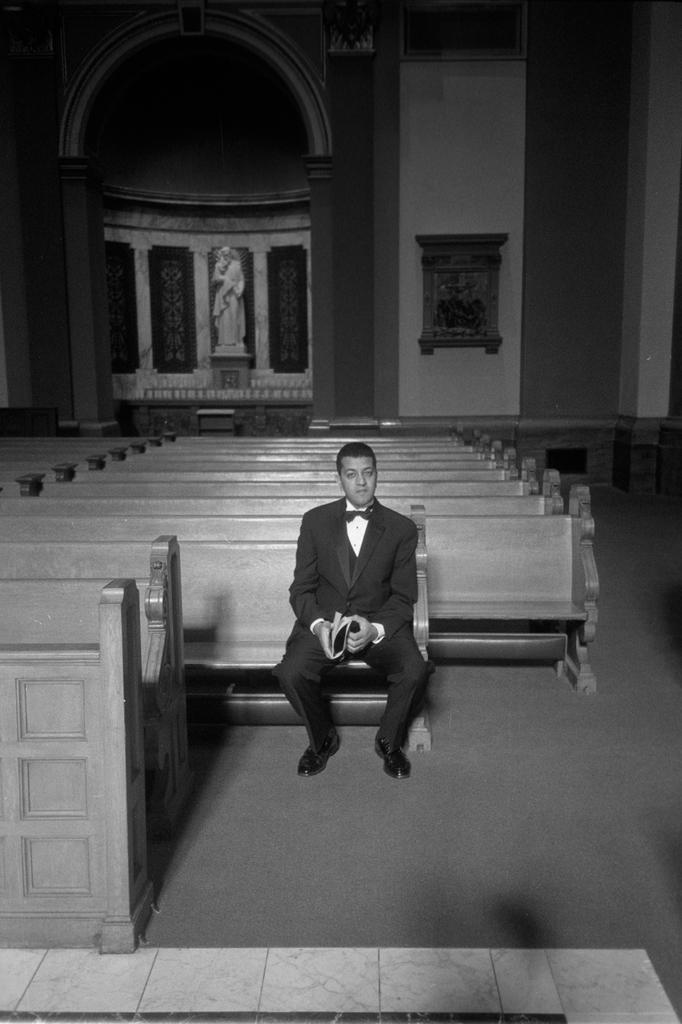What is the color scheme of the image? The image is black and white. Can you describe the person in the image? There is a person in the image, and they are wearing clothes. What is the person doing in the image? The person is sitting on a bench. What other objects are present in the image? There is a sculpture and additional benches in the image. What type of powder is being used to stop the person from moving in the image? There is no powder or indication of stopping movement in the image; the person is simply sitting on a bench. 